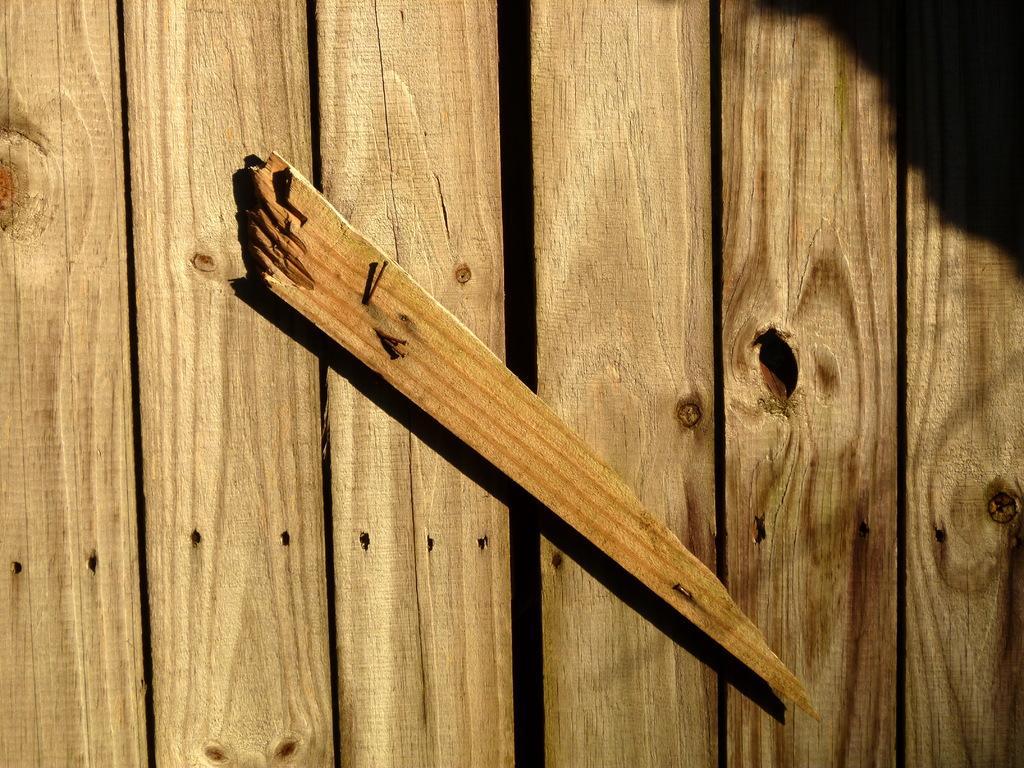How would you summarize this image in a sentence or two? In the picture we can see a wooden planks wall with a wooden stick fixed on it. 